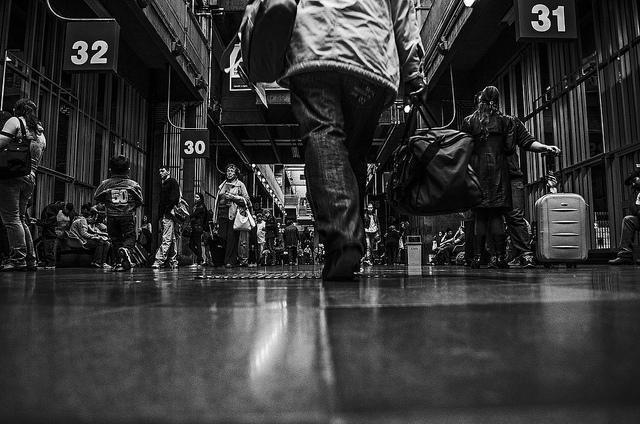How many handbags are visible?
Give a very brief answer. 2. How many people can be seen?
Give a very brief answer. 7. 